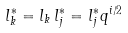<formula> <loc_0><loc_0><loc_500><loc_500>l ^ { \ast } _ { k } = l _ { k } \, l ^ { \ast } _ { j } = l ^ { \ast } _ { j } q ^ { i / 2 }</formula> 